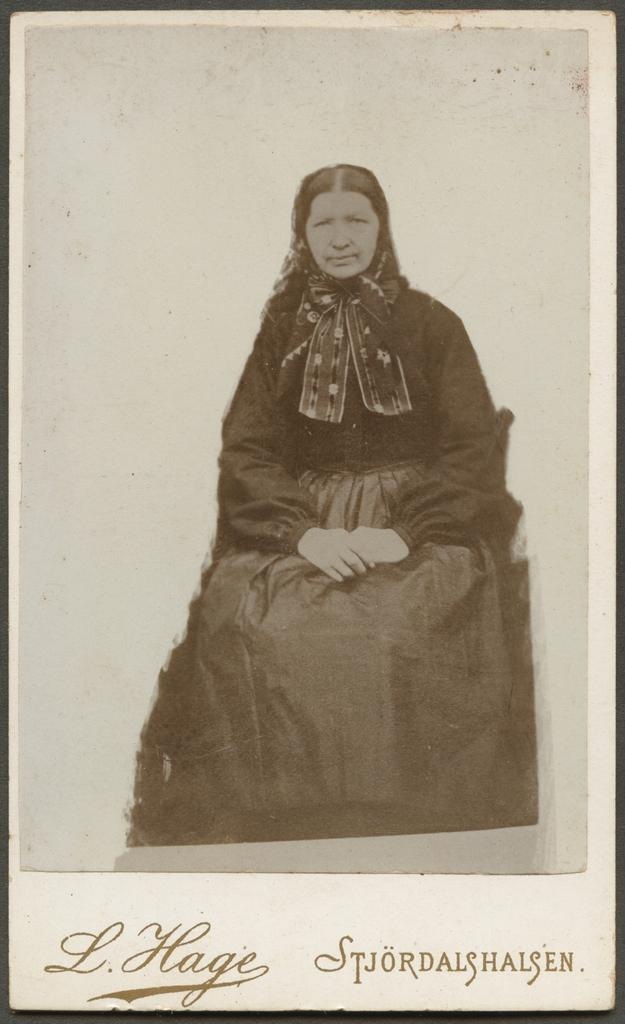What is the position of the woman in the image? The woman is sitting in the image. What else can be seen at the bottom of the image? There is text at the bottom of the image. What type of fan is the woman using in the image? There is no fan present in the image. 